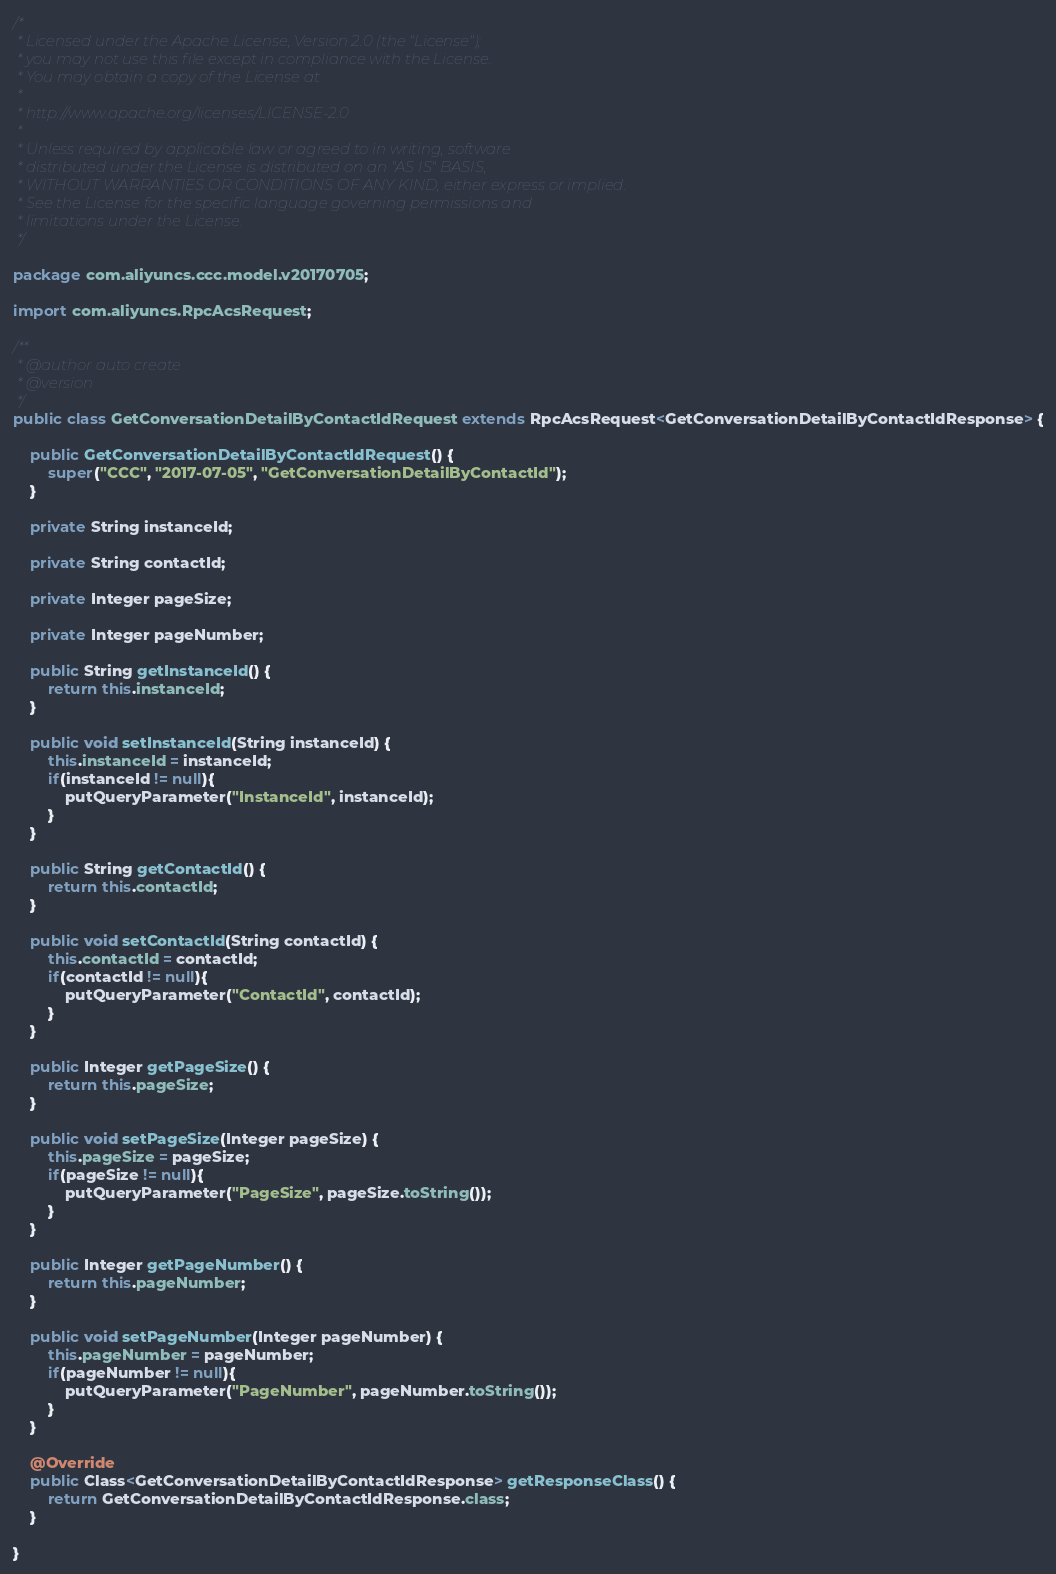Convert code to text. <code><loc_0><loc_0><loc_500><loc_500><_Java_>/*
 * Licensed under the Apache License, Version 2.0 (the "License");
 * you may not use this file except in compliance with the License.
 * You may obtain a copy of the License at
 *
 * http://www.apache.org/licenses/LICENSE-2.0
 *
 * Unless required by applicable law or agreed to in writing, software
 * distributed under the License is distributed on an "AS IS" BASIS,
 * WITHOUT WARRANTIES OR CONDITIONS OF ANY KIND, either express or implied.
 * See the License for the specific language governing permissions and
 * limitations under the License.
 */

package com.aliyuncs.ccc.model.v20170705;

import com.aliyuncs.RpcAcsRequest;

/**
 * @author auto create
 * @version 
 */
public class GetConversationDetailByContactIdRequest extends RpcAcsRequest<GetConversationDetailByContactIdResponse> {
	
	public GetConversationDetailByContactIdRequest() {
		super("CCC", "2017-07-05", "GetConversationDetailByContactId");
	}

	private String instanceId;

	private String contactId;

	private Integer pageSize;

	private Integer pageNumber;

	public String getInstanceId() {
		return this.instanceId;
	}

	public void setInstanceId(String instanceId) {
		this.instanceId = instanceId;
		if(instanceId != null){
			putQueryParameter("InstanceId", instanceId);
		}
	}

	public String getContactId() {
		return this.contactId;
	}

	public void setContactId(String contactId) {
		this.contactId = contactId;
		if(contactId != null){
			putQueryParameter("ContactId", contactId);
		}
	}

	public Integer getPageSize() {
		return this.pageSize;
	}

	public void setPageSize(Integer pageSize) {
		this.pageSize = pageSize;
		if(pageSize != null){
			putQueryParameter("PageSize", pageSize.toString());
		}
	}

	public Integer getPageNumber() {
		return this.pageNumber;
	}

	public void setPageNumber(Integer pageNumber) {
		this.pageNumber = pageNumber;
		if(pageNumber != null){
			putQueryParameter("PageNumber", pageNumber.toString());
		}
	}

	@Override
	public Class<GetConversationDetailByContactIdResponse> getResponseClass() {
		return GetConversationDetailByContactIdResponse.class;
	}

}
</code> 